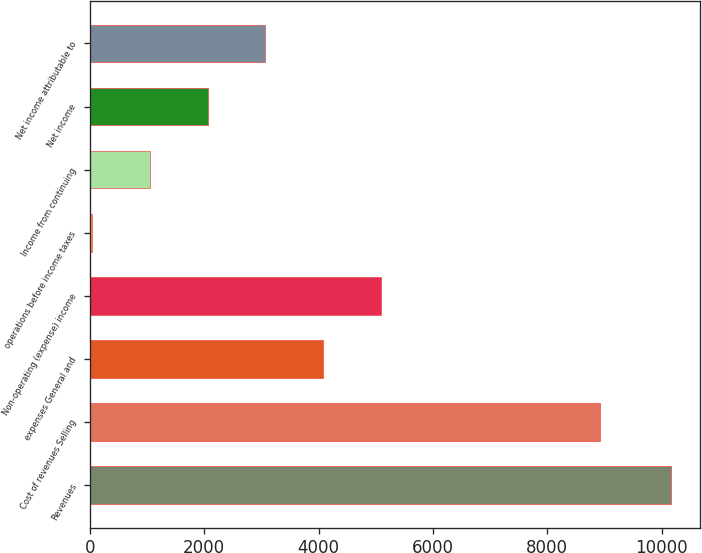Convert chart. <chart><loc_0><loc_0><loc_500><loc_500><bar_chart><fcel>Revenues<fcel>Cost of revenues Selling<fcel>expenses General and<fcel>Non-operating (expense) income<fcel>operations before income taxes<fcel>Income from continuing<fcel>Net income<fcel>Net income attributable to<nl><fcel>10170<fcel>8923<fcel>4085.4<fcel>5099.5<fcel>29<fcel>1043.1<fcel>2057.2<fcel>3071.3<nl></chart> 